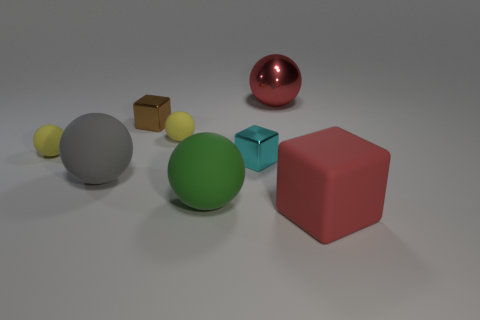Subtract all gray cylinders. How many yellow balls are left? 2 Subtract all green balls. How many balls are left? 4 Subtract all gray spheres. How many spheres are left? 4 Subtract 1 blocks. How many blocks are left? 2 Add 1 big gray matte spheres. How many objects exist? 9 Subtract all green balls. Subtract all brown cubes. How many balls are left? 4 Subtract all balls. How many objects are left? 3 Add 5 green things. How many green things are left? 6 Add 8 small metal things. How many small metal things exist? 10 Subtract 0 purple cylinders. How many objects are left? 8 